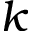<formula> <loc_0><loc_0><loc_500><loc_500>k</formula> 